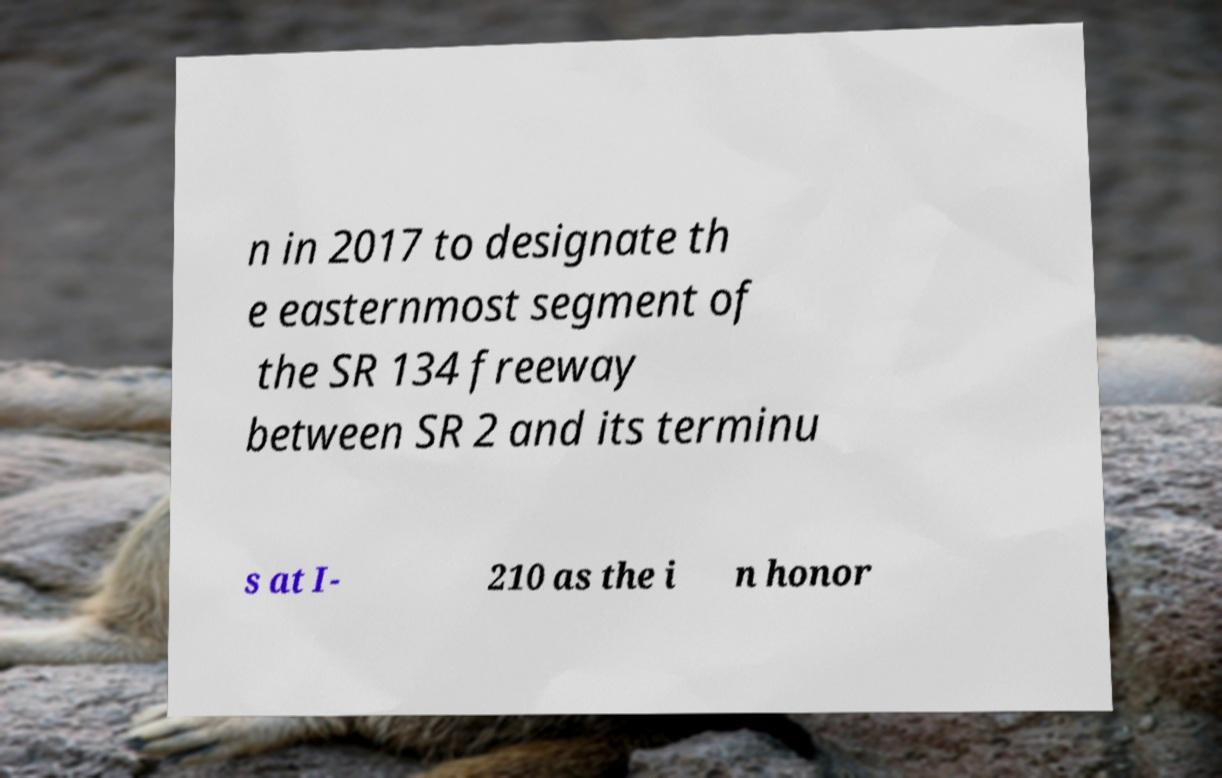I need the written content from this picture converted into text. Can you do that? n in 2017 to designate th e easternmost segment of the SR 134 freeway between SR 2 and its terminu s at I- 210 as the i n honor 